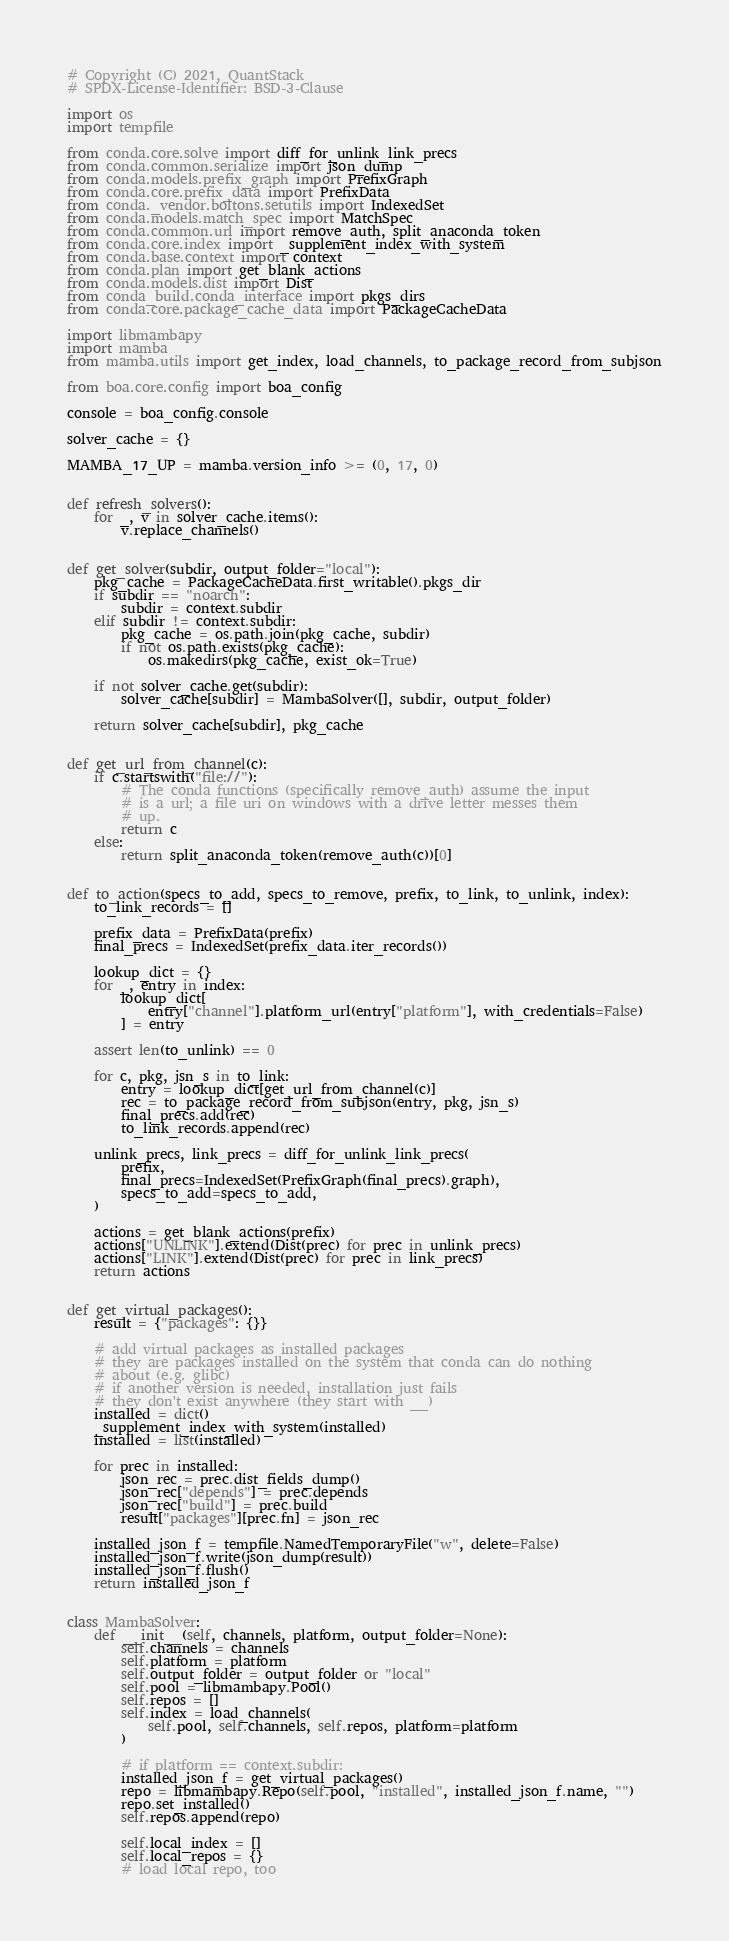Convert code to text. <code><loc_0><loc_0><loc_500><loc_500><_Python_># Copyright (C) 2021, QuantStack
# SPDX-License-Identifier: BSD-3-Clause

import os
import tempfile

from conda.core.solve import diff_for_unlink_link_precs
from conda.common.serialize import json_dump
from conda.models.prefix_graph import PrefixGraph
from conda.core.prefix_data import PrefixData
from conda._vendor.boltons.setutils import IndexedSet
from conda.models.match_spec import MatchSpec
from conda.common.url import remove_auth, split_anaconda_token
from conda.core.index import _supplement_index_with_system
from conda.base.context import context
from conda.plan import get_blank_actions
from conda.models.dist import Dist
from conda_build.conda_interface import pkgs_dirs
from conda.core.package_cache_data import PackageCacheData

import libmambapy
import mamba
from mamba.utils import get_index, load_channels, to_package_record_from_subjson

from boa.core.config import boa_config

console = boa_config.console

solver_cache = {}

MAMBA_17_UP = mamba.version_info >= (0, 17, 0)


def refresh_solvers():
    for _, v in solver_cache.items():
        v.replace_channels()


def get_solver(subdir, output_folder="local"):
    pkg_cache = PackageCacheData.first_writable().pkgs_dir
    if subdir == "noarch":
        subdir = context.subdir
    elif subdir != context.subdir:
        pkg_cache = os.path.join(pkg_cache, subdir)
        if not os.path.exists(pkg_cache):
            os.makedirs(pkg_cache, exist_ok=True)

    if not solver_cache.get(subdir):
        solver_cache[subdir] = MambaSolver([], subdir, output_folder)

    return solver_cache[subdir], pkg_cache


def get_url_from_channel(c):
    if c.startswith("file://"):
        # The conda functions (specifically remove_auth) assume the input
        # is a url; a file uri on windows with a drive letter messes them
        # up.
        return c
    else:
        return split_anaconda_token(remove_auth(c))[0]


def to_action(specs_to_add, specs_to_remove, prefix, to_link, to_unlink, index):
    to_link_records = []

    prefix_data = PrefixData(prefix)
    final_precs = IndexedSet(prefix_data.iter_records())

    lookup_dict = {}
    for _, entry in index:
        lookup_dict[
            entry["channel"].platform_url(entry["platform"], with_credentials=False)
        ] = entry

    assert len(to_unlink) == 0

    for c, pkg, jsn_s in to_link:
        entry = lookup_dict[get_url_from_channel(c)]
        rec = to_package_record_from_subjson(entry, pkg, jsn_s)
        final_precs.add(rec)
        to_link_records.append(rec)

    unlink_precs, link_precs = diff_for_unlink_link_precs(
        prefix,
        final_precs=IndexedSet(PrefixGraph(final_precs).graph),
        specs_to_add=specs_to_add,
    )

    actions = get_blank_actions(prefix)
    actions["UNLINK"].extend(Dist(prec) for prec in unlink_precs)
    actions["LINK"].extend(Dist(prec) for prec in link_precs)
    return actions


def get_virtual_packages():
    result = {"packages": {}}

    # add virtual packages as installed packages
    # they are packages installed on the system that conda can do nothing
    # about (e.g. glibc)
    # if another version is needed, installation just fails
    # they don't exist anywhere (they start with __)
    installed = dict()
    _supplement_index_with_system(installed)
    installed = list(installed)

    for prec in installed:
        json_rec = prec.dist_fields_dump()
        json_rec["depends"] = prec.depends
        json_rec["build"] = prec.build
        result["packages"][prec.fn] = json_rec

    installed_json_f = tempfile.NamedTemporaryFile("w", delete=False)
    installed_json_f.write(json_dump(result))
    installed_json_f.flush()
    return installed_json_f


class MambaSolver:
    def __init__(self, channels, platform, output_folder=None):
        self.channels = channels
        self.platform = platform
        self.output_folder = output_folder or "local"
        self.pool = libmambapy.Pool()
        self.repos = []
        self.index = load_channels(
            self.pool, self.channels, self.repos, platform=platform
        )

        # if platform == context.subdir:
        installed_json_f = get_virtual_packages()
        repo = libmambapy.Repo(self.pool, "installed", installed_json_f.name, "")
        repo.set_installed()
        self.repos.append(repo)

        self.local_index = []
        self.local_repos = {}
        # load local repo, too</code> 